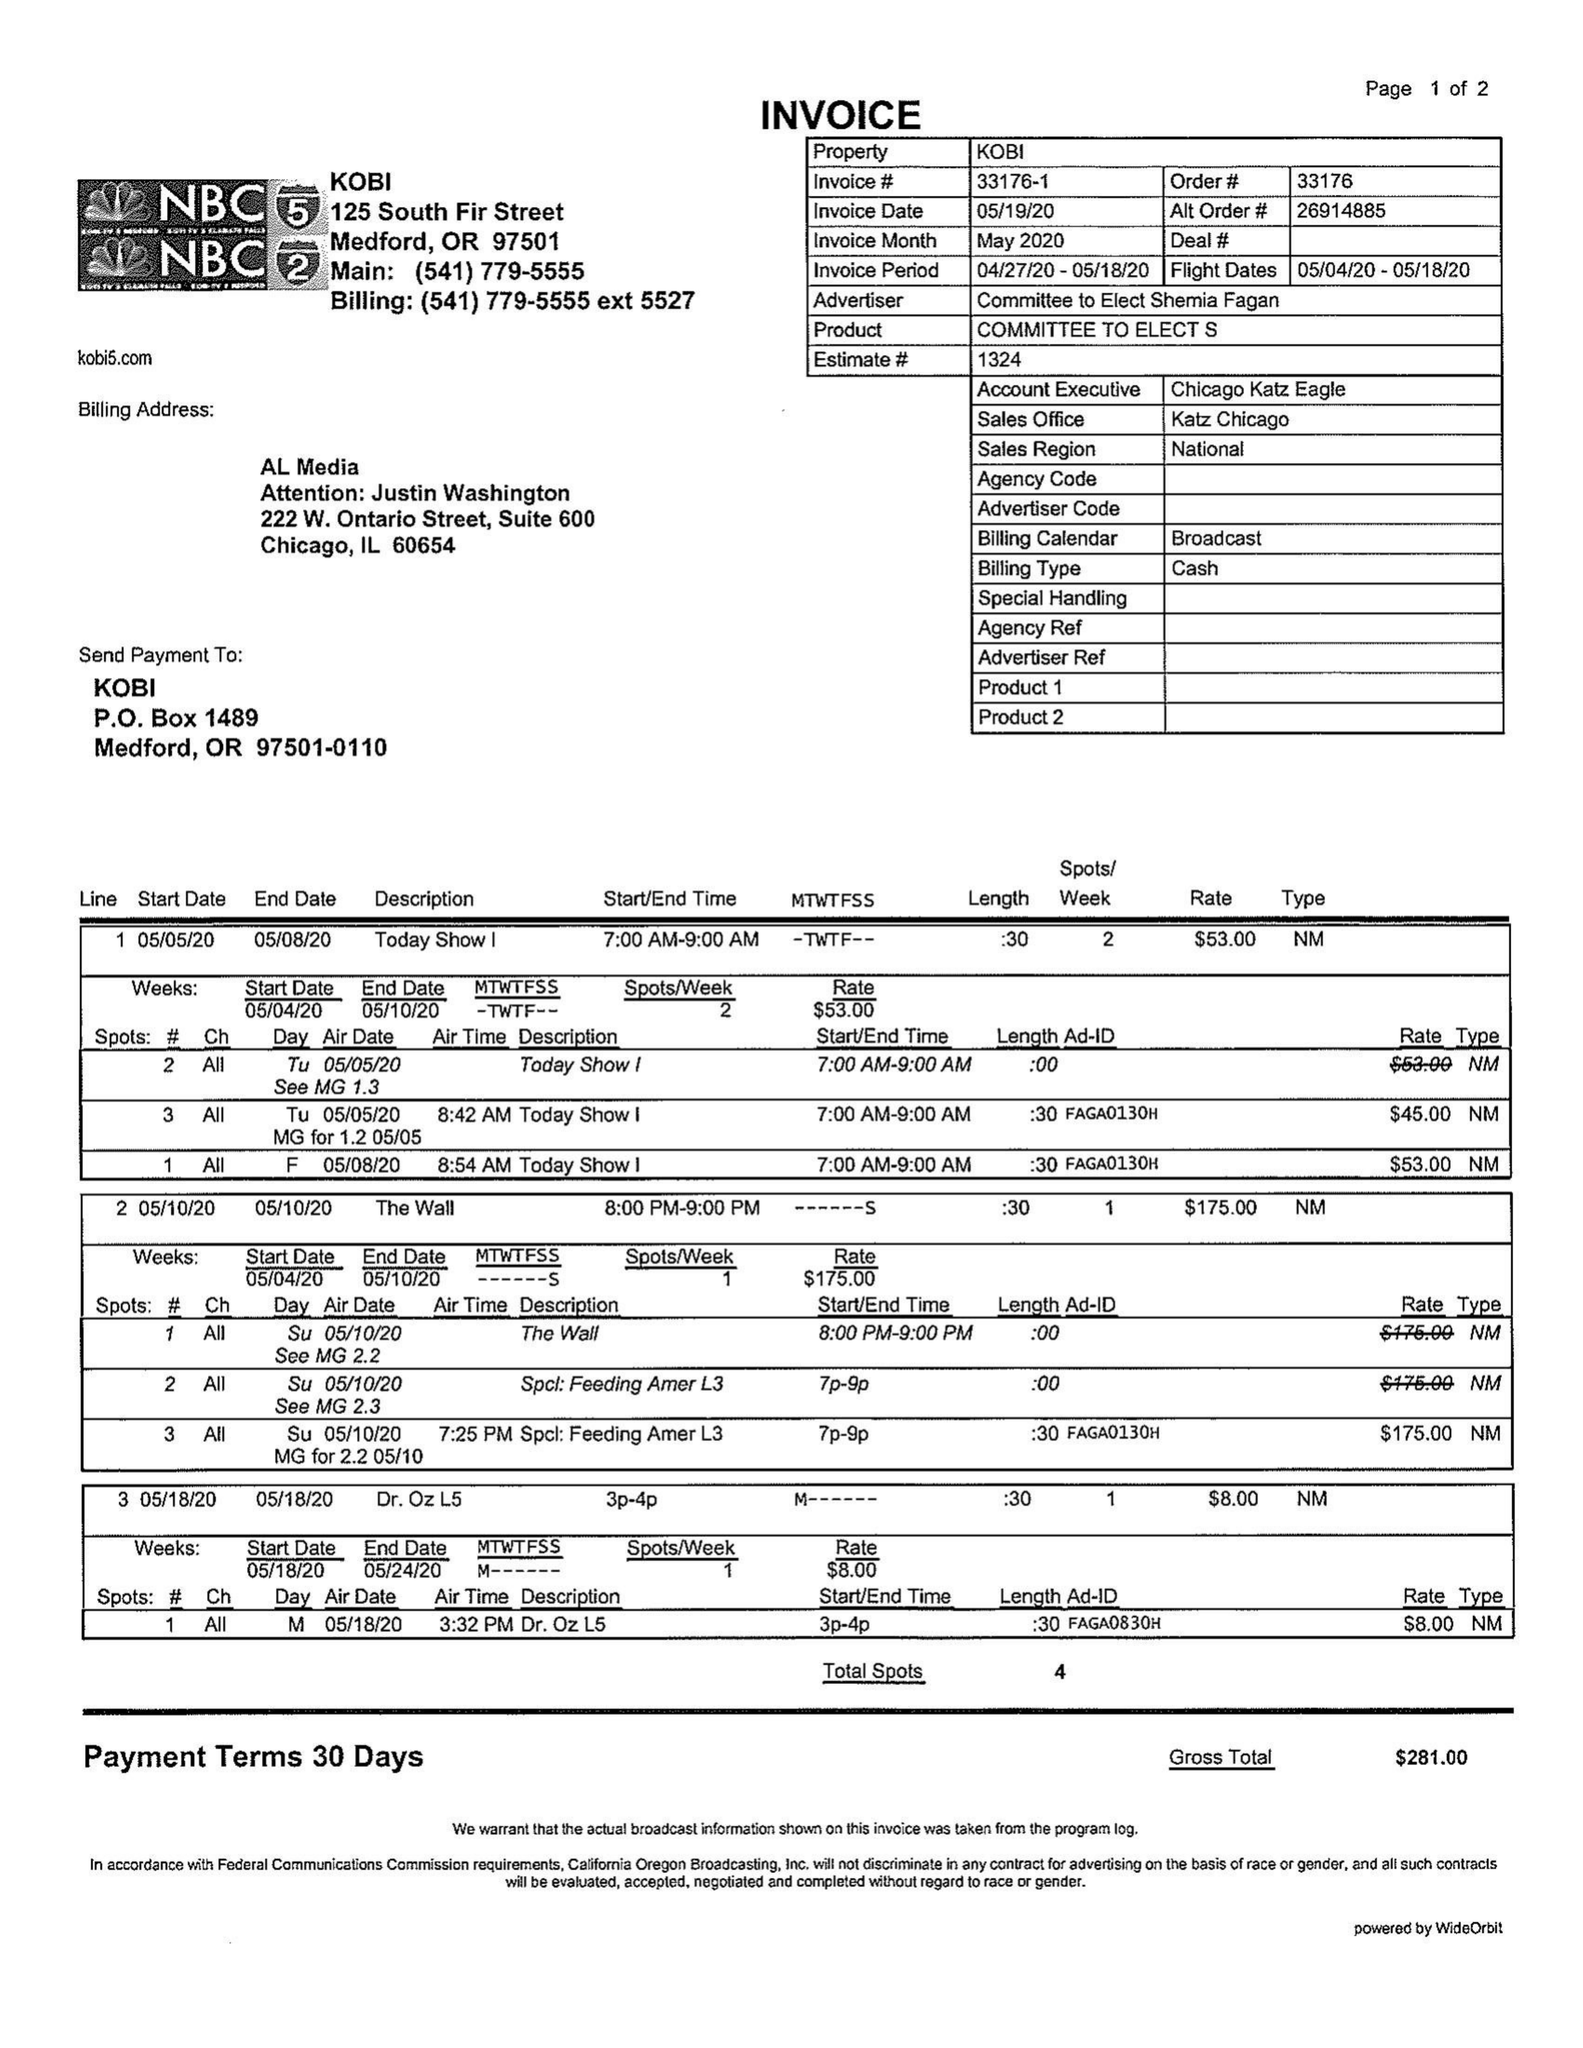What is the value for the gross_amount?
Answer the question using a single word or phrase. 281.00 